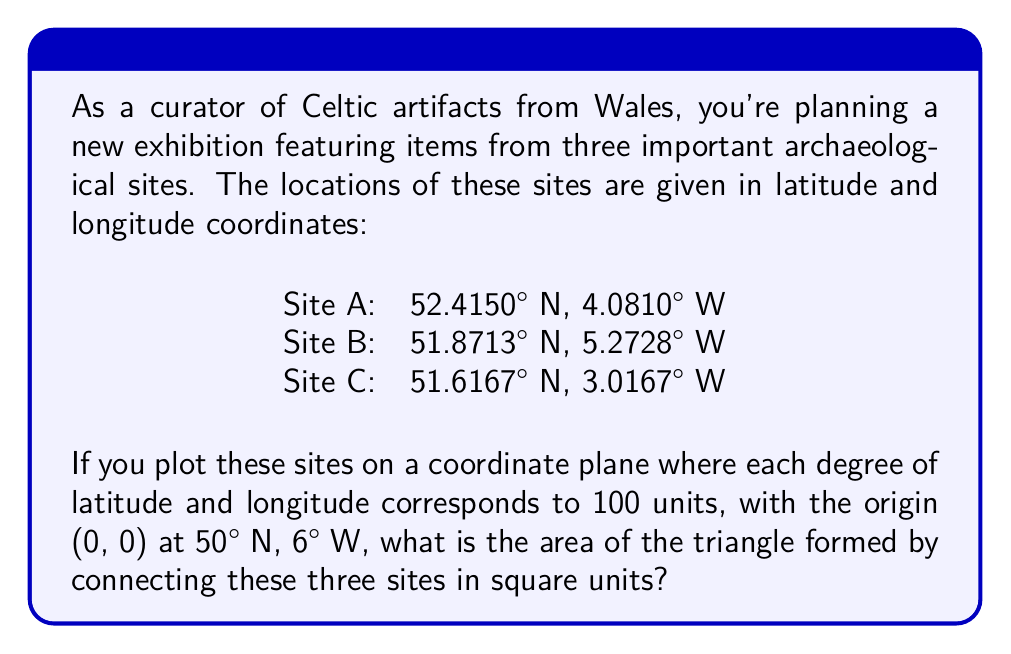Provide a solution to this math problem. To solve this problem, we need to follow these steps:

1) First, convert the given coordinates to our coordinate system:
   - Site A: (52.4150° N, 4.0810° W) → (240.15, 191.90)
   - Site B: (51.8713° N, 5.2728° W) → (187.13, 72.72)
   - Site C: (51.6167° N, 3.0167° W) → (161.67, 298.33)

   The conversion is done by:
   x = (latitude - 50) * 100
   y = (6 - longitude) * 100

2) Now we have three points on a coordinate plane:
   A(240.15, 191.90), B(187.13, 72.72), C(161.67, 298.33)

3) To find the area of a triangle given three points, we can use the formula:

   $$\text{Area} = \frac{1}{2}|x_1(y_2 - y_3) + x_2(y_3 - y_1) + x_3(y_1 - y_2)|$$

   Where $(x_1, y_1)$, $(x_2, y_2)$, and $(x_3, y_3)$ are the coordinates of the three points.

4) Substituting our values:

   $$\text{Area} = \frac{1}{2}|240.15(72.72 - 298.33) + 187.13(298.33 - 191.90) + 161.67(191.90 - 72.72)|$$

5) Simplifying:

   $$\text{Area} = \frac{1}{2}|240.15(-225.61) + 187.13(106.43) + 161.67(119.18)|$$
   $$= \frac{1}{2}|-54183.38 + 19916.35 + 19267.43|$$
   $$= \frac{1}{2}|-14999.60|$$
   $$= \frac{1}{2}(14999.60)$$
   $$= 7499.80$$

Therefore, the area of the triangle is approximately 7499.80 square units.
Answer: 7499.80 square units 